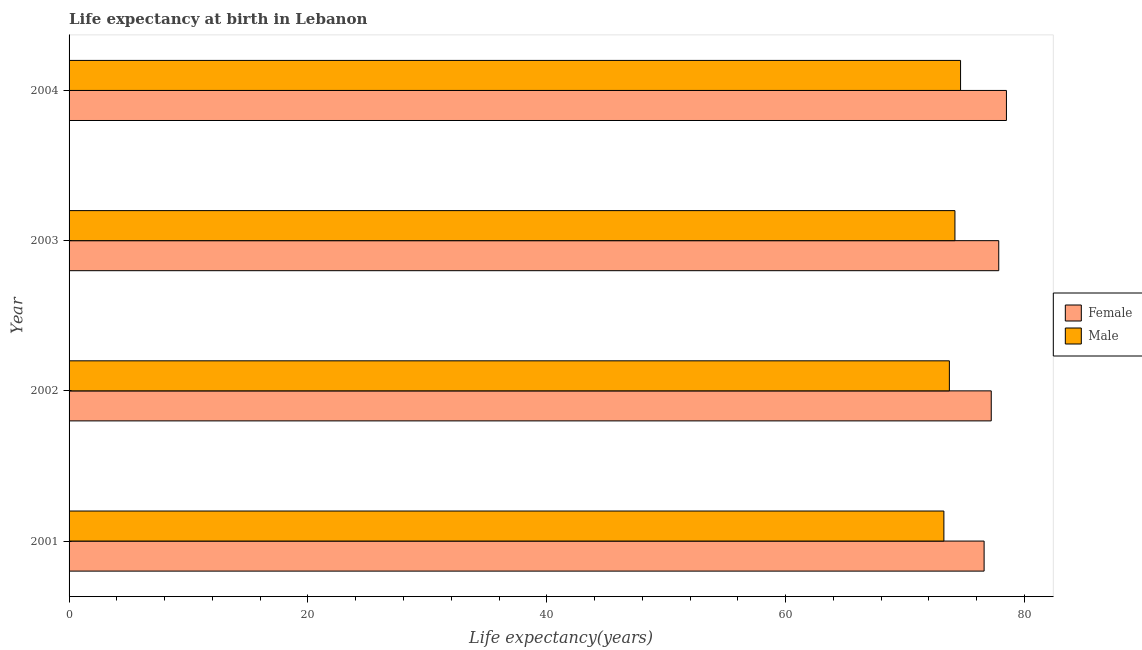How many different coloured bars are there?
Your response must be concise. 2. Are the number of bars per tick equal to the number of legend labels?
Your answer should be very brief. Yes. Are the number of bars on each tick of the Y-axis equal?
Your answer should be very brief. Yes. How many bars are there on the 1st tick from the top?
Provide a short and direct response. 2. How many bars are there on the 1st tick from the bottom?
Provide a succinct answer. 2. What is the life expectancy(male) in 2002?
Offer a very short reply. 73.71. Across all years, what is the maximum life expectancy(female)?
Your answer should be very brief. 78.49. Across all years, what is the minimum life expectancy(male)?
Offer a very short reply. 73.25. In which year was the life expectancy(female) maximum?
Provide a short and direct response. 2004. What is the total life expectancy(female) in the graph?
Provide a succinct answer. 310.17. What is the difference between the life expectancy(male) in 2003 and that in 2004?
Provide a short and direct response. -0.47. What is the difference between the life expectancy(male) in 2001 and the life expectancy(female) in 2003?
Give a very brief answer. -4.59. What is the average life expectancy(female) per year?
Keep it short and to the point. 77.54. In the year 2002, what is the difference between the life expectancy(female) and life expectancy(male)?
Provide a succinct answer. 3.51. In how many years, is the life expectancy(male) greater than 72 years?
Make the answer very short. 4. What is the ratio of the life expectancy(male) in 2002 to that in 2004?
Provide a succinct answer. 0.99. What is the difference between the highest and the second highest life expectancy(female)?
Make the answer very short. 0.64. What is the difference between the highest and the lowest life expectancy(male)?
Offer a terse response. 1.4. In how many years, is the life expectancy(female) greater than the average life expectancy(female) taken over all years?
Your answer should be very brief. 2. Is the sum of the life expectancy(male) in 2002 and 2003 greater than the maximum life expectancy(female) across all years?
Your answer should be very brief. Yes. What does the 1st bar from the bottom in 2002 represents?
Offer a very short reply. Female. What is the difference between two consecutive major ticks on the X-axis?
Keep it short and to the point. 20. Where does the legend appear in the graph?
Your answer should be very brief. Center right. What is the title of the graph?
Provide a short and direct response. Life expectancy at birth in Lebanon. Does "Underweight" appear as one of the legend labels in the graph?
Give a very brief answer. No. What is the label or title of the X-axis?
Your answer should be very brief. Life expectancy(years). What is the label or title of the Y-axis?
Your response must be concise. Year. What is the Life expectancy(years) of Female in 2001?
Give a very brief answer. 76.62. What is the Life expectancy(years) of Male in 2001?
Your response must be concise. 73.25. What is the Life expectancy(years) of Female in 2002?
Provide a short and direct response. 77.22. What is the Life expectancy(years) in Male in 2002?
Your answer should be compact. 73.71. What is the Life expectancy(years) of Female in 2003?
Your answer should be very brief. 77.84. What is the Life expectancy(years) in Male in 2003?
Your response must be concise. 74.18. What is the Life expectancy(years) of Female in 2004?
Ensure brevity in your answer.  78.49. What is the Life expectancy(years) of Male in 2004?
Your response must be concise. 74.65. Across all years, what is the maximum Life expectancy(years) of Female?
Your answer should be very brief. 78.49. Across all years, what is the maximum Life expectancy(years) in Male?
Ensure brevity in your answer.  74.65. Across all years, what is the minimum Life expectancy(years) in Female?
Provide a short and direct response. 76.62. Across all years, what is the minimum Life expectancy(years) of Male?
Provide a succinct answer. 73.25. What is the total Life expectancy(years) of Female in the graph?
Your response must be concise. 310.17. What is the total Life expectancy(years) of Male in the graph?
Give a very brief answer. 295.79. What is the difference between the Life expectancy(years) in Female in 2001 and that in 2002?
Your answer should be very brief. -0.6. What is the difference between the Life expectancy(years) in Male in 2001 and that in 2002?
Keep it short and to the point. -0.46. What is the difference between the Life expectancy(years) in Female in 2001 and that in 2003?
Offer a terse response. -1.23. What is the difference between the Life expectancy(years) in Male in 2001 and that in 2003?
Keep it short and to the point. -0.93. What is the difference between the Life expectancy(years) of Female in 2001 and that in 2004?
Offer a very short reply. -1.87. What is the difference between the Life expectancy(years) in Male in 2001 and that in 2004?
Your response must be concise. -1.4. What is the difference between the Life expectancy(years) of Female in 2002 and that in 2003?
Provide a succinct answer. -0.63. What is the difference between the Life expectancy(years) in Male in 2002 and that in 2003?
Your answer should be very brief. -0.47. What is the difference between the Life expectancy(years) in Female in 2002 and that in 2004?
Your answer should be compact. -1.27. What is the difference between the Life expectancy(years) in Male in 2002 and that in 2004?
Provide a succinct answer. -0.94. What is the difference between the Life expectancy(years) of Female in 2003 and that in 2004?
Make the answer very short. -0.64. What is the difference between the Life expectancy(years) in Male in 2003 and that in 2004?
Your answer should be compact. -0.47. What is the difference between the Life expectancy(years) of Female in 2001 and the Life expectancy(years) of Male in 2002?
Give a very brief answer. 2.91. What is the difference between the Life expectancy(years) in Female in 2001 and the Life expectancy(years) in Male in 2003?
Your answer should be very brief. 2.44. What is the difference between the Life expectancy(years) in Female in 2001 and the Life expectancy(years) in Male in 2004?
Give a very brief answer. 1.97. What is the difference between the Life expectancy(years) in Female in 2002 and the Life expectancy(years) in Male in 2003?
Your answer should be compact. 3.04. What is the difference between the Life expectancy(years) of Female in 2002 and the Life expectancy(years) of Male in 2004?
Provide a succinct answer. 2.57. What is the difference between the Life expectancy(years) in Female in 2003 and the Life expectancy(years) in Male in 2004?
Give a very brief answer. 3.2. What is the average Life expectancy(years) in Female per year?
Provide a succinct answer. 77.54. What is the average Life expectancy(years) of Male per year?
Your answer should be compact. 73.95. In the year 2001, what is the difference between the Life expectancy(years) in Female and Life expectancy(years) in Male?
Your answer should be compact. 3.37. In the year 2002, what is the difference between the Life expectancy(years) of Female and Life expectancy(years) of Male?
Your response must be concise. 3.51. In the year 2003, what is the difference between the Life expectancy(years) in Female and Life expectancy(years) in Male?
Your answer should be compact. 3.67. In the year 2004, what is the difference between the Life expectancy(years) in Female and Life expectancy(years) in Male?
Offer a terse response. 3.84. What is the ratio of the Life expectancy(years) in Male in 2001 to that in 2002?
Your answer should be compact. 0.99. What is the ratio of the Life expectancy(years) in Female in 2001 to that in 2003?
Your response must be concise. 0.98. What is the ratio of the Life expectancy(years) in Male in 2001 to that in 2003?
Offer a terse response. 0.99. What is the ratio of the Life expectancy(years) of Female in 2001 to that in 2004?
Your answer should be compact. 0.98. What is the ratio of the Life expectancy(years) of Male in 2001 to that in 2004?
Give a very brief answer. 0.98. What is the ratio of the Life expectancy(years) in Female in 2002 to that in 2003?
Your answer should be compact. 0.99. What is the ratio of the Life expectancy(years) in Male in 2002 to that in 2003?
Your answer should be compact. 0.99. What is the ratio of the Life expectancy(years) of Female in 2002 to that in 2004?
Offer a terse response. 0.98. What is the ratio of the Life expectancy(years) of Male in 2002 to that in 2004?
Offer a terse response. 0.99. What is the ratio of the Life expectancy(years) of Female in 2003 to that in 2004?
Your answer should be compact. 0.99. What is the ratio of the Life expectancy(years) of Male in 2003 to that in 2004?
Your answer should be very brief. 0.99. What is the difference between the highest and the second highest Life expectancy(years) in Female?
Make the answer very short. 0.64. What is the difference between the highest and the second highest Life expectancy(years) of Male?
Your response must be concise. 0.47. What is the difference between the highest and the lowest Life expectancy(years) in Female?
Offer a terse response. 1.87. What is the difference between the highest and the lowest Life expectancy(years) of Male?
Keep it short and to the point. 1.4. 